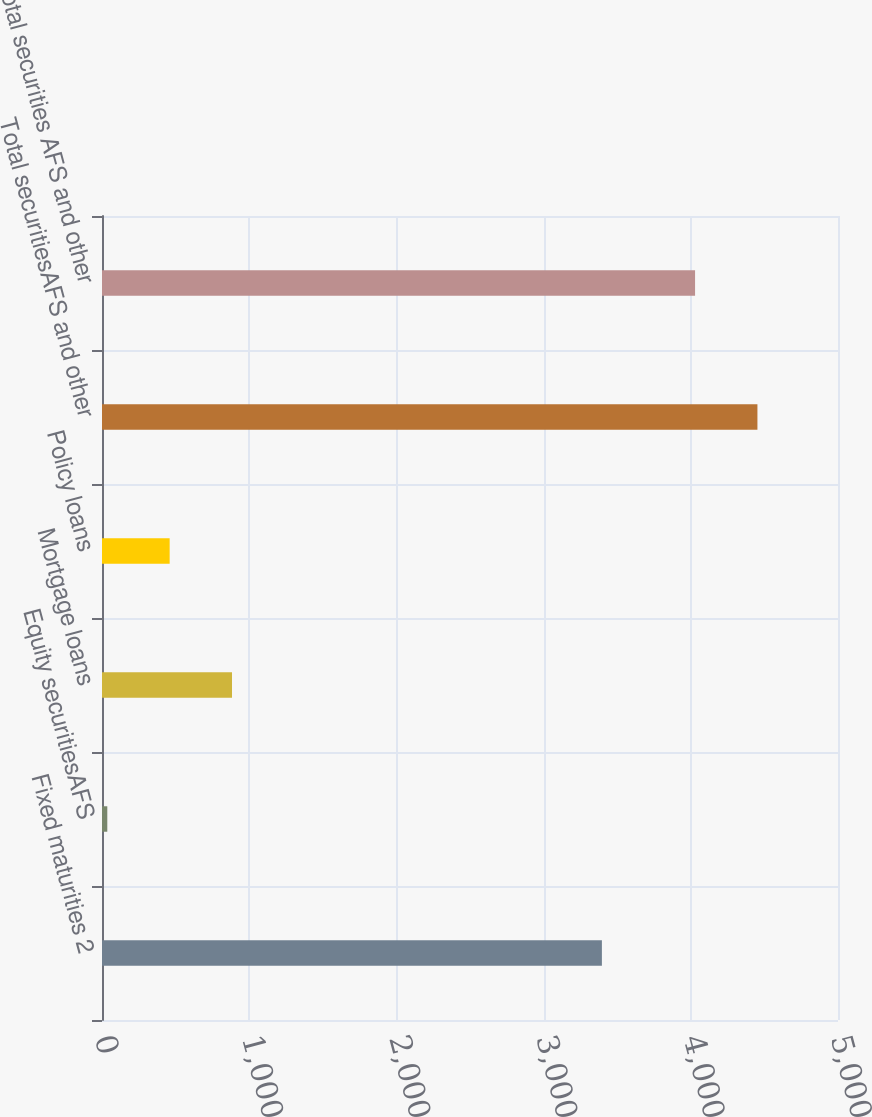<chart> <loc_0><loc_0><loc_500><loc_500><bar_chart><fcel>Fixed maturities 2<fcel>Equity securitiesAFS<fcel>Mortgage loans<fcel>Policy loans<fcel>Total securitiesAFS and other<fcel>Total securities AFS and other<nl><fcel>3396<fcel>36<fcel>883.2<fcel>459.6<fcel>4452.6<fcel>4029<nl></chart> 